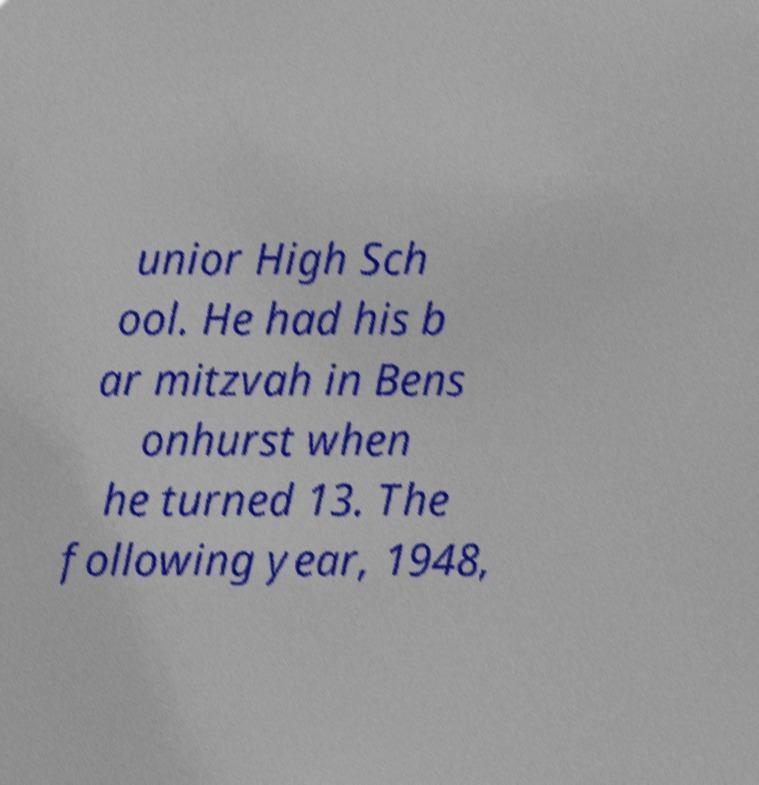Please identify and transcribe the text found in this image. unior High Sch ool. He had his b ar mitzvah in Bens onhurst when he turned 13. The following year, 1948, 